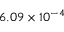<formula> <loc_0><loc_0><loc_500><loc_500>6 . 0 9 \times 1 0 ^ { - 4 }</formula> 